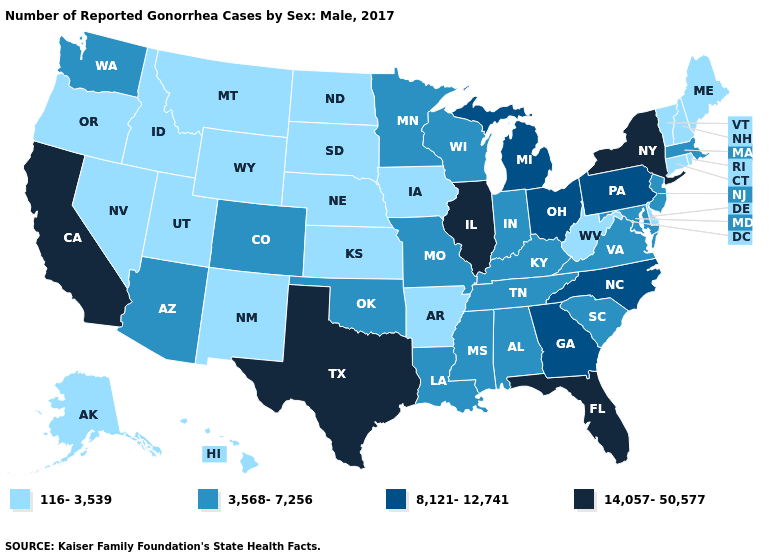What is the highest value in states that border Alabama?
Short answer required. 14,057-50,577. What is the value of New Jersey?
Answer briefly. 3,568-7,256. Which states have the lowest value in the USA?
Keep it brief. Alaska, Arkansas, Connecticut, Delaware, Hawaii, Idaho, Iowa, Kansas, Maine, Montana, Nebraska, Nevada, New Hampshire, New Mexico, North Dakota, Oregon, Rhode Island, South Dakota, Utah, Vermont, West Virginia, Wyoming. Among the states that border Delaware , which have the highest value?
Answer briefly. Pennsylvania. What is the lowest value in states that border Michigan?
Keep it brief. 3,568-7,256. What is the lowest value in the USA?
Write a very short answer. 116-3,539. What is the value of Iowa?
Be succinct. 116-3,539. Does the map have missing data?
Quick response, please. No. What is the value of New Mexico?
Be succinct. 116-3,539. Name the states that have a value in the range 3,568-7,256?
Write a very short answer. Alabama, Arizona, Colorado, Indiana, Kentucky, Louisiana, Maryland, Massachusetts, Minnesota, Mississippi, Missouri, New Jersey, Oklahoma, South Carolina, Tennessee, Virginia, Washington, Wisconsin. Which states hav the highest value in the Northeast?
Keep it brief. New York. What is the highest value in states that border Virginia?
Quick response, please. 8,121-12,741. Does Tennessee have the lowest value in the South?
Answer briefly. No. What is the value of Virginia?
Give a very brief answer. 3,568-7,256. Does the map have missing data?
Be succinct. No. 